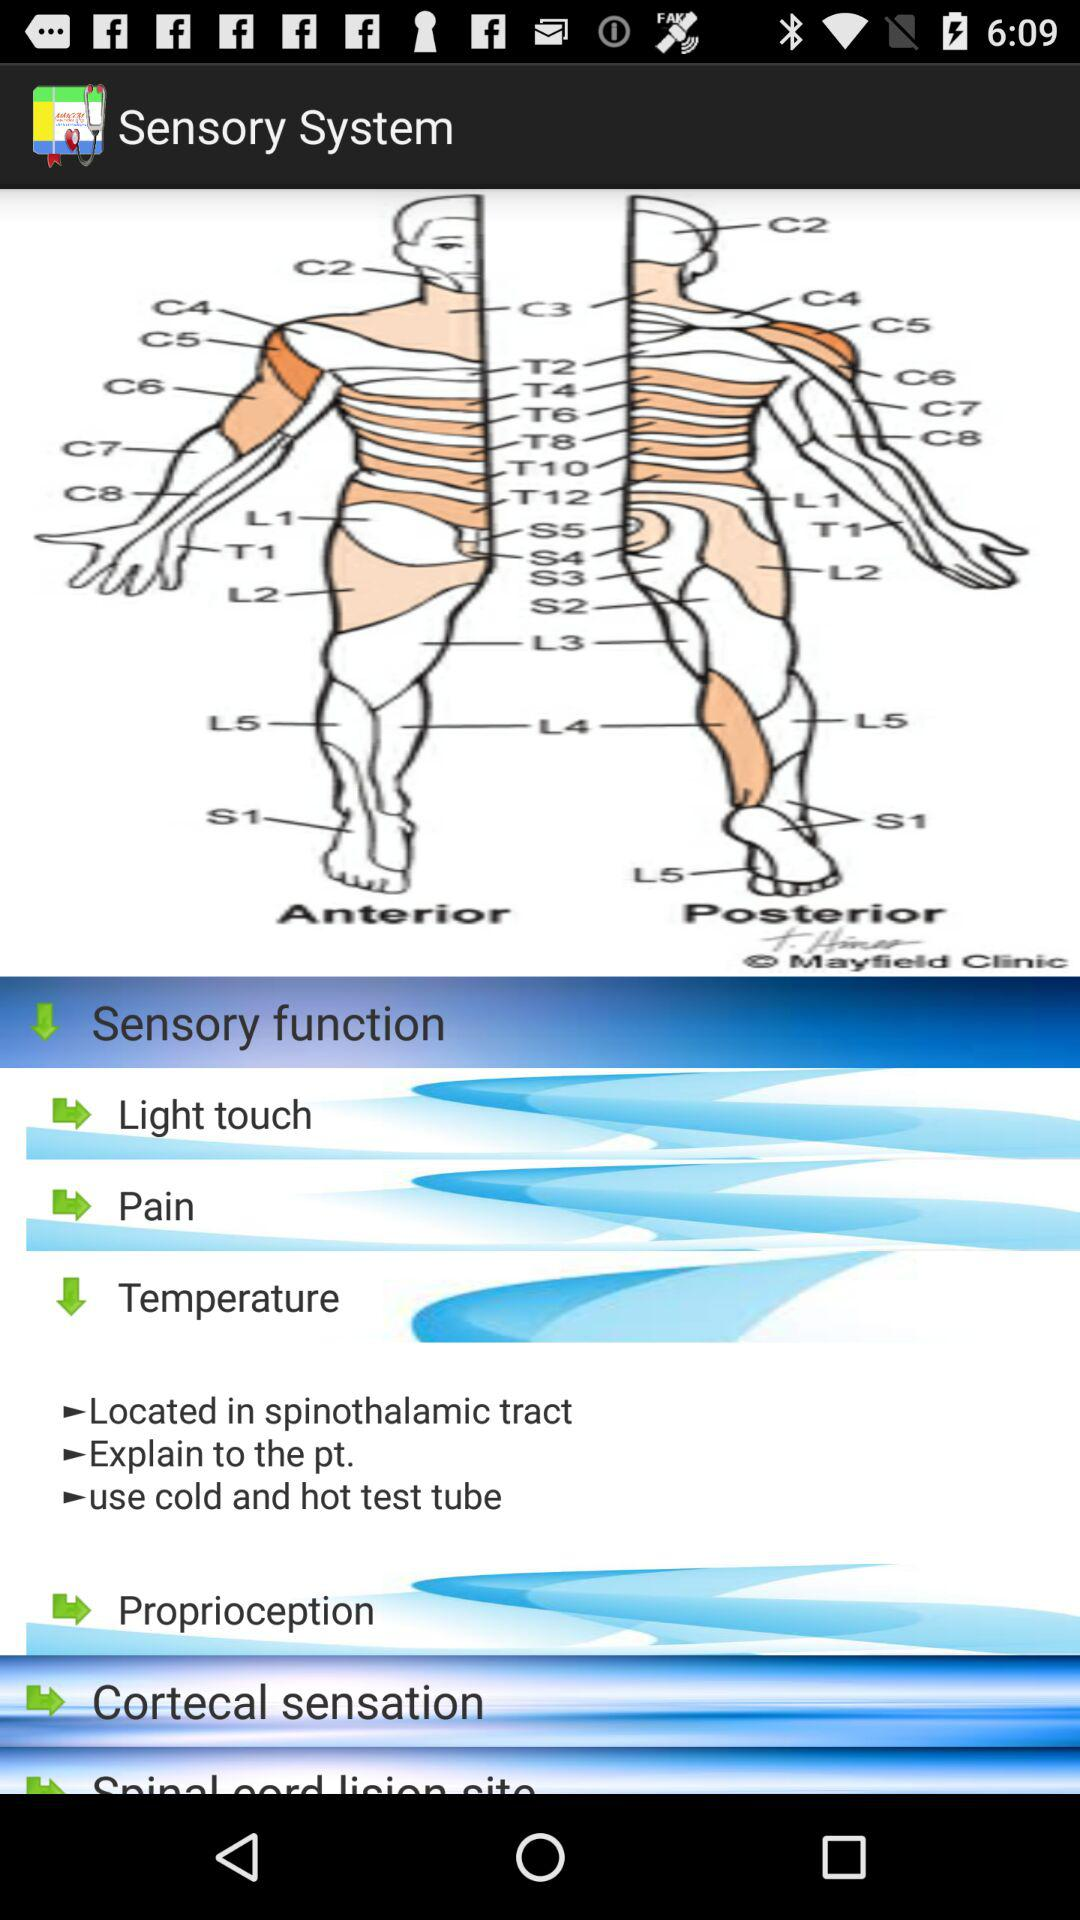What is the application name? The application name is "Sensory System". 